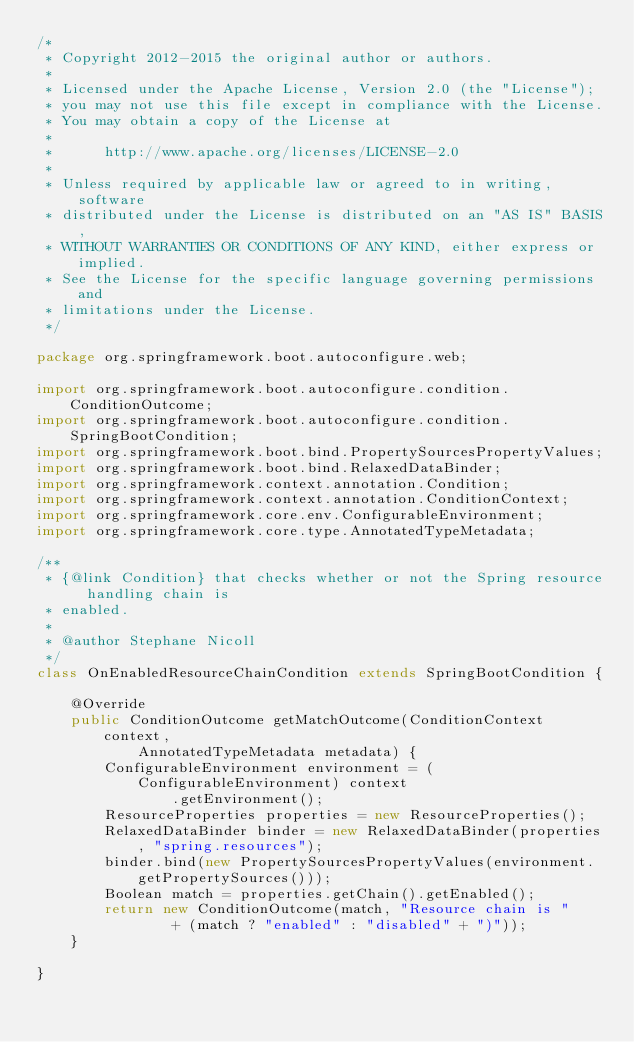Convert code to text. <code><loc_0><loc_0><loc_500><loc_500><_Java_>/*
 * Copyright 2012-2015 the original author or authors.
 *
 * Licensed under the Apache License, Version 2.0 (the "License");
 * you may not use this file except in compliance with the License.
 * You may obtain a copy of the License at
 *
 *      http://www.apache.org/licenses/LICENSE-2.0
 *
 * Unless required by applicable law or agreed to in writing, software
 * distributed under the License is distributed on an "AS IS" BASIS,
 * WITHOUT WARRANTIES OR CONDITIONS OF ANY KIND, either express or implied.
 * See the License for the specific language governing permissions and
 * limitations under the License.
 */

package org.springframework.boot.autoconfigure.web;

import org.springframework.boot.autoconfigure.condition.ConditionOutcome;
import org.springframework.boot.autoconfigure.condition.SpringBootCondition;
import org.springframework.boot.bind.PropertySourcesPropertyValues;
import org.springframework.boot.bind.RelaxedDataBinder;
import org.springframework.context.annotation.Condition;
import org.springframework.context.annotation.ConditionContext;
import org.springframework.core.env.ConfigurableEnvironment;
import org.springframework.core.type.AnnotatedTypeMetadata;

/**
 * {@link Condition} that checks whether or not the Spring resource handling chain is
 * enabled.
 *
 * @author Stephane Nicoll
 */
class OnEnabledResourceChainCondition extends SpringBootCondition {

	@Override
	public ConditionOutcome getMatchOutcome(ConditionContext context,
			AnnotatedTypeMetadata metadata) {
		ConfigurableEnvironment environment = (ConfigurableEnvironment) context
				.getEnvironment();
		ResourceProperties properties = new ResourceProperties();
		RelaxedDataBinder binder = new RelaxedDataBinder(properties, "spring.resources");
		binder.bind(new PropertySourcesPropertyValues(environment.getPropertySources()));
		Boolean match = properties.getChain().getEnabled();
		return new ConditionOutcome(match, "Resource chain is "
				+ (match ? "enabled" : "disabled" + ")"));
	}

}
</code> 